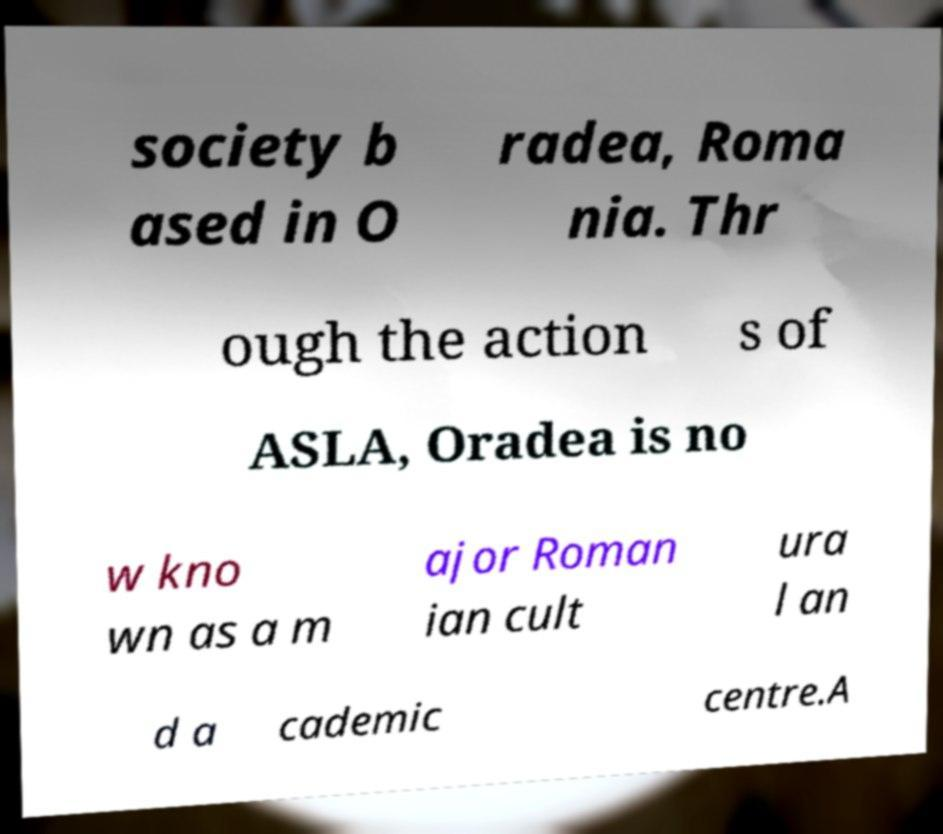I need the written content from this picture converted into text. Can you do that? society b ased in O radea, Roma nia. Thr ough the action s of ASLA, Oradea is no w kno wn as a m ajor Roman ian cult ura l an d a cademic centre.A 